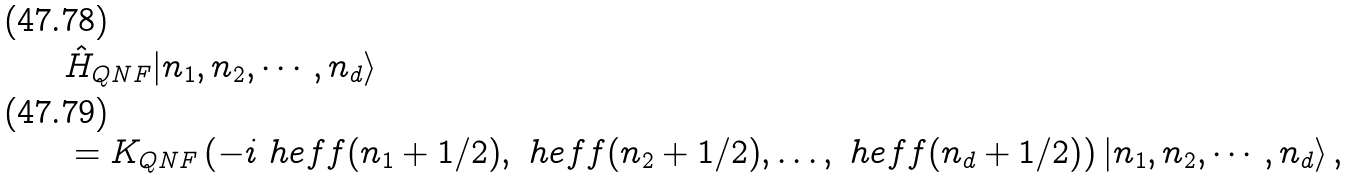<formula> <loc_0><loc_0><loc_500><loc_500>& \hat { H } _ { Q N F } | n _ { 1 } , n _ { 2 } , \cdots , n _ { d } \rangle \\ & = K _ { Q N F } \left ( - i \ h e f f ( n _ { 1 } + 1 / 2 ) , \ h e f f ( n _ { 2 } + 1 / 2 ) , \dots , \ h e f f ( n _ { d } + 1 / 2 ) \right ) | n _ { 1 } , n _ { 2 } , \cdots , n _ { d } \rangle \, ,</formula> 